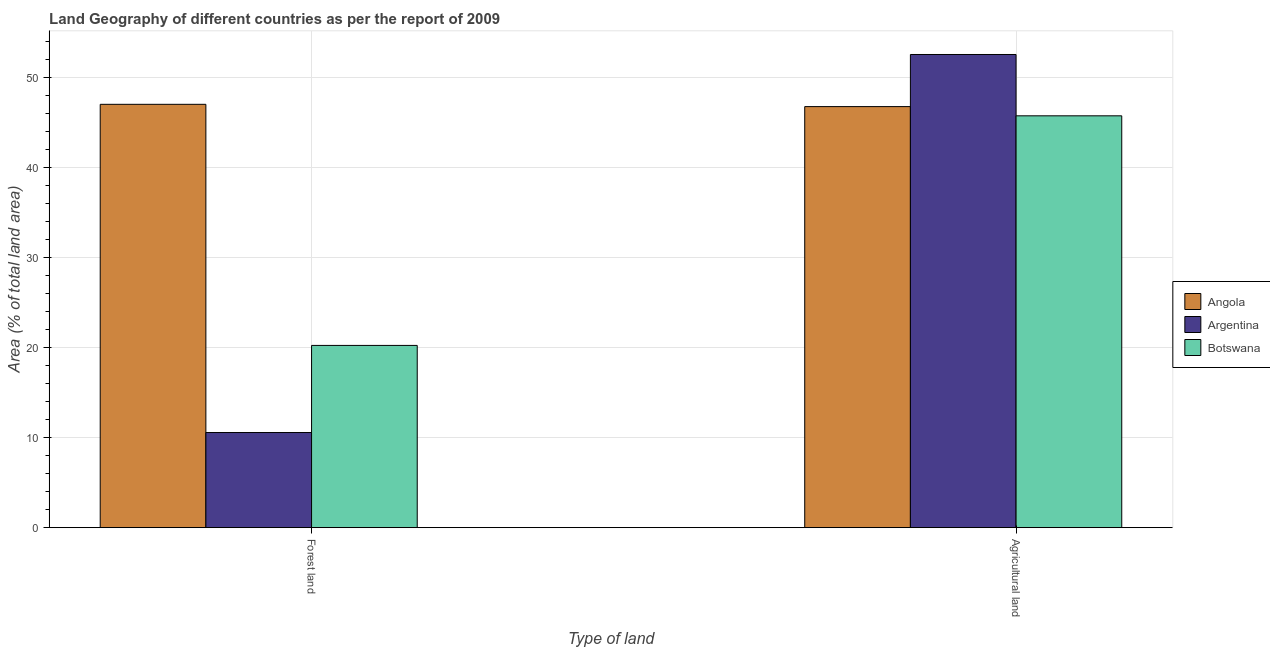How many different coloured bars are there?
Ensure brevity in your answer.  3. How many bars are there on the 1st tick from the left?
Make the answer very short. 3. How many bars are there on the 1st tick from the right?
Keep it short and to the point. 3. What is the label of the 2nd group of bars from the left?
Your response must be concise. Agricultural land. What is the percentage of land area under agriculture in Argentina?
Offer a terse response. 52.54. Across all countries, what is the maximum percentage of land area under forests?
Your answer should be very brief. 47.01. Across all countries, what is the minimum percentage of land area under forests?
Your answer should be very brief. 10.57. In which country was the percentage of land area under forests maximum?
Make the answer very short. Angola. What is the total percentage of land area under agriculture in the graph?
Ensure brevity in your answer.  145.03. What is the difference between the percentage of land area under agriculture in Argentina and that in Botswana?
Offer a very short reply. 6.81. What is the difference between the percentage of land area under forests in Botswana and the percentage of land area under agriculture in Argentina?
Offer a terse response. -32.3. What is the average percentage of land area under agriculture per country?
Offer a very short reply. 48.34. What is the difference between the percentage of land area under agriculture and percentage of land area under forests in Angola?
Provide a short and direct response. -0.25. In how many countries, is the percentage of land area under forests greater than 40 %?
Give a very brief answer. 1. What is the ratio of the percentage of land area under forests in Botswana to that in Angola?
Give a very brief answer. 0.43. In how many countries, is the percentage of land area under forests greater than the average percentage of land area under forests taken over all countries?
Make the answer very short. 1. What does the 3rd bar from the left in Forest land represents?
Your answer should be compact. Botswana. What does the 2nd bar from the right in Agricultural land represents?
Ensure brevity in your answer.  Argentina. How many bars are there?
Offer a terse response. 6. Are all the bars in the graph horizontal?
Offer a terse response. No. How many countries are there in the graph?
Your answer should be compact. 3. What is the difference between two consecutive major ticks on the Y-axis?
Offer a very short reply. 10. Does the graph contain any zero values?
Ensure brevity in your answer.  No. How many legend labels are there?
Offer a very short reply. 3. How are the legend labels stacked?
Keep it short and to the point. Vertical. What is the title of the graph?
Your answer should be compact. Land Geography of different countries as per the report of 2009. Does "Korea (Republic)" appear as one of the legend labels in the graph?
Provide a short and direct response. No. What is the label or title of the X-axis?
Provide a succinct answer. Type of land. What is the label or title of the Y-axis?
Your answer should be compact. Area (% of total land area). What is the Area (% of total land area) of Angola in Forest land?
Provide a short and direct response. 47.01. What is the Area (% of total land area) of Argentina in Forest land?
Provide a succinct answer. 10.57. What is the Area (% of total land area) in Botswana in Forest land?
Offer a very short reply. 20.24. What is the Area (% of total land area) of Angola in Agricultural land?
Your answer should be very brief. 46.76. What is the Area (% of total land area) in Argentina in Agricultural land?
Provide a short and direct response. 52.54. What is the Area (% of total land area) of Botswana in Agricultural land?
Your response must be concise. 45.73. Across all Type of land, what is the maximum Area (% of total land area) in Angola?
Give a very brief answer. 47.01. Across all Type of land, what is the maximum Area (% of total land area) in Argentina?
Ensure brevity in your answer.  52.54. Across all Type of land, what is the maximum Area (% of total land area) of Botswana?
Offer a very short reply. 45.73. Across all Type of land, what is the minimum Area (% of total land area) of Angola?
Make the answer very short. 46.76. Across all Type of land, what is the minimum Area (% of total land area) of Argentina?
Offer a terse response. 10.57. Across all Type of land, what is the minimum Area (% of total land area) of Botswana?
Your answer should be very brief. 20.24. What is the total Area (% of total land area) in Angola in the graph?
Offer a very short reply. 93.76. What is the total Area (% of total land area) in Argentina in the graph?
Keep it short and to the point. 63.11. What is the total Area (% of total land area) of Botswana in the graph?
Keep it short and to the point. 65.97. What is the difference between the Area (% of total land area) of Angola in Forest land and that in Agricultural land?
Your response must be concise. 0.25. What is the difference between the Area (% of total land area) in Argentina in Forest land and that in Agricultural land?
Provide a short and direct response. -41.98. What is the difference between the Area (% of total land area) of Botswana in Forest land and that in Agricultural land?
Your answer should be very brief. -25.49. What is the difference between the Area (% of total land area) of Angola in Forest land and the Area (% of total land area) of Argentina in Agricultural land?
Make the answer very short. -5.53. What is the difference between the Area (% of total land area) of Angola in Forest land and the Area (% of total land area) of Botswana in Agricultural land?
Ensure brevity in your answer.  1.28. What is the difference between the Area (% of total land area) in Argentina in Forest land and the Area (% of total land area) in Botswana in Agricultural land?
Provide a succinct answer. -35.17. What is the average Area (% of total land area) in Angola per Type of land?
Your response must be concise. 46.88. What is the average Area (% of total land area) in Argentina per Type of land?
Keep it short and to the point. 31.55. What is the average Area (% of total land area) in Botswana per Type of land?
Offer a terse response. 32.99. What is the difference between the Area (% of total land area) in Angola and Area (% of total land area) in Argentina in Forest land?
Keep it short and to the point. 36.44. What is the difference between the Area (% of total land area) in Angola and Area (% of total land area) in Botswana in Forest land?
Provide a short and direct response. 26.77. What is the difference between the Area (% of total land area) in Argentina and Area (% of total land area) in Botswana in Forest land?
Provide a short and direct response. -9.67. What is the difference between the Area (% of total land area) in Angola and Area (% of total land area) in Argentina in Agricultural land?
Your answer should be very brief. -5.79. What is the difference between the Area (% of total land area) in Angola and Area (% of total land area) in Botswana in Agricultural land?
Make the answer very short. 1.02. What is the difference between the Area (% of total land area) in Argentina and Area (% of total land area) in Botswana in Agricultural land?
Provide a succinct answer. 6.81. What is the ratio of the Area (% of total land area) in Angola in Forest land to that in Agricultural land?
Your answer should be compact. 1.01. What is the ratio of the Area (% of total land area) in Argentina in Forest land to that in Agricultural land?
Your answer should be very brief. 0.2. What is the ratio of the Area (% of total land area) of Botswana in Forest land to that in Agricultural land?
Give a very brief answer. 0.44. What is the difference between the highest and the second highest Area (% of total land area) of Angola?
Your answer should be compact. 0.25. What is the difference between the highest and the second highest Area (% of total land area) in Argentina?
Provide a short and direct response. 41.98. What is the difference between the highest and the second highest Area (% of total land area) in Botswana?
Offer a terse response. 25.49. What is the difference between the highest and the lowest Area (% of total land area) in Angola?
Make the answer very short. 0.25. What is the difference between the highest and the lowest Area (% of total land area) of Argentina?
Make the answer very short. 41.98. What is the difference between the highest and the lowest Area (% of total land area) of Botswana?
Keep it short and to the point. 25.49. 